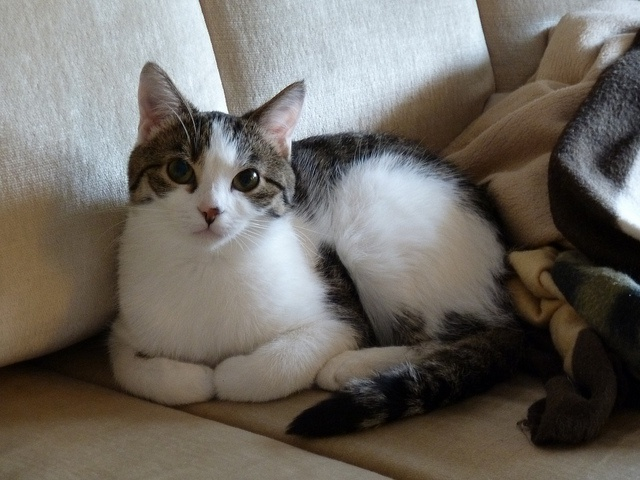Describe the objects in this image and their specific colors. I can see couch in darkgray, gray, and lightgray tones and cat in darkgray, gray, and black tones in this image. 